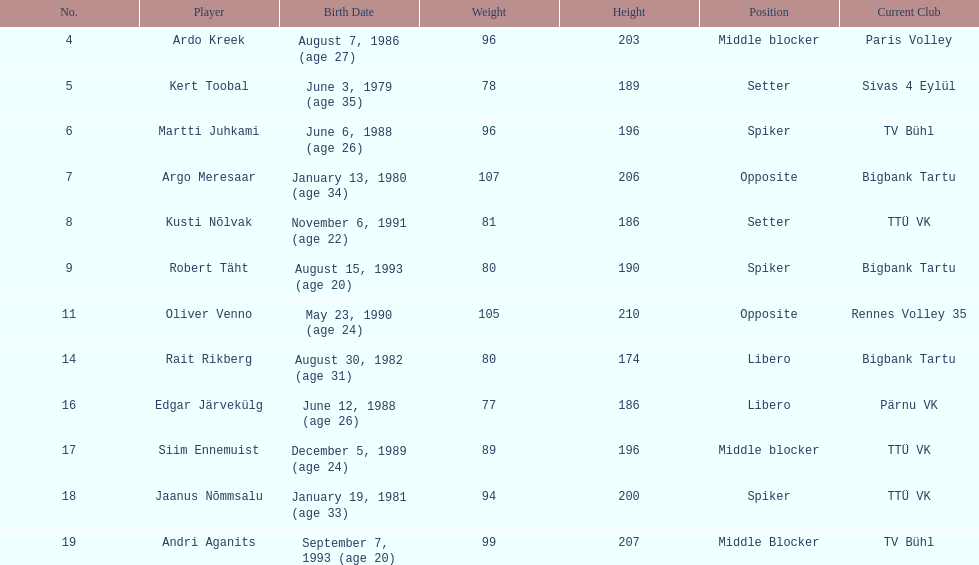How many individuals from estonia's men's national volleyball team have a birth year of 1988? 2. 